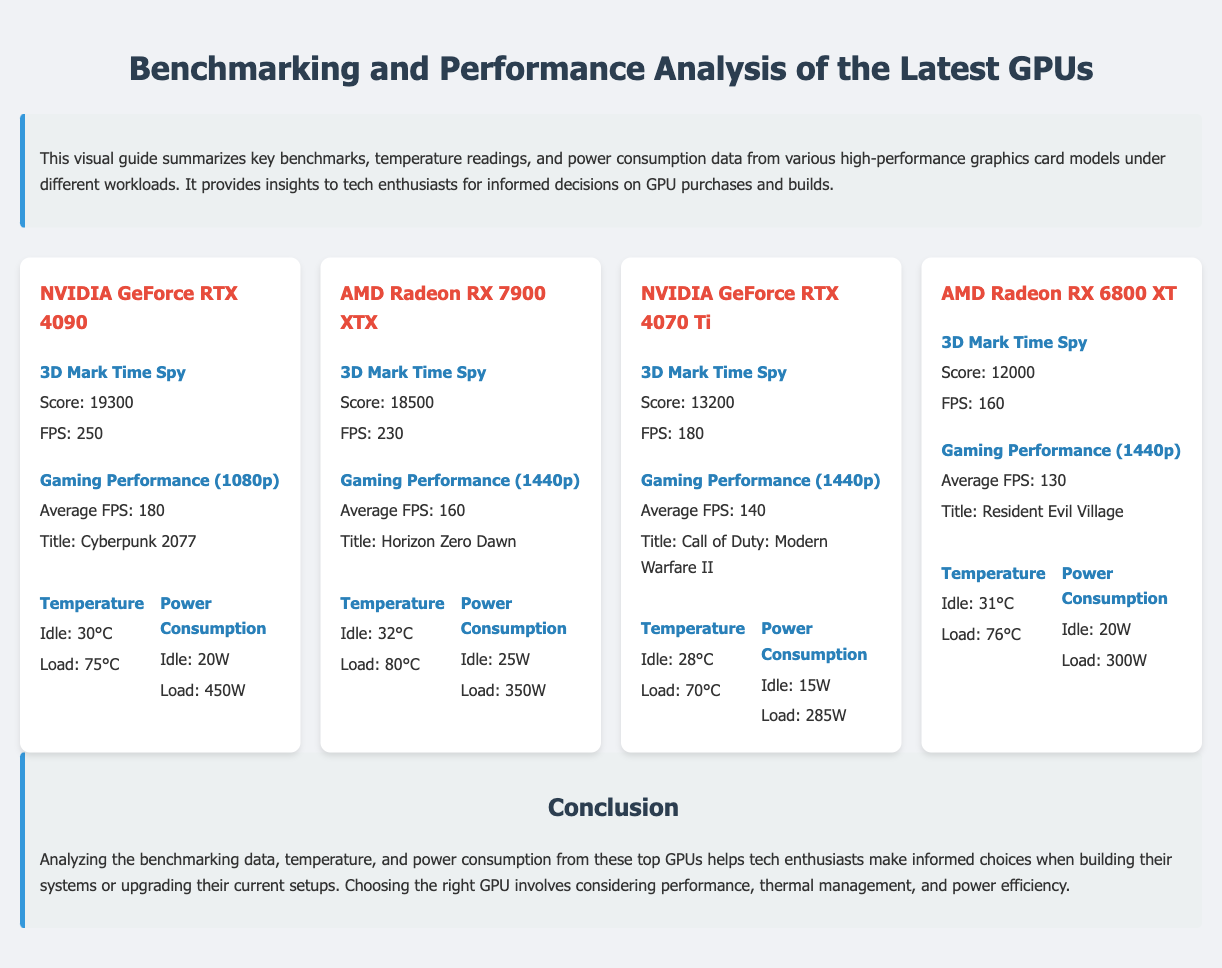What is the benchmark score for NVIDIA GeForce RTX 4090? The benchmark score for NVIDIA GeForce RTX 4090 is found in the section displaying the 3D Mark Time Spy results, which shows a score of 19300.
Answer: 19300 What is the average FPS of AMD Radeon RX 7900 XTX in Gaming Performance at 1440p? The average FPS for AMD Radeon RX 7900 XTX at 1440p is listed under Gaming Performance, showing 160 FPS for the title Horizon Zero Dawn.
Answer: 160 Which GPU has the highest power consumption at load? By analyzing power consumption data at load for all GPUs, it can be concluded that the NVIDIA GeForce RTX 4090 has the highest power consumption at 450W.
Answer: 450W What is the idle temperature of NVIDIA GeForce RTX 4070 Ti? The idle temperature for NVIDIA GeForce RTX 4070 Ti is presented in the temperature readings, showing 28°C when idle.
Answer: 28°C Which GPU has the lowest score in the 3D Mark Time Spy benchmark? The lowest score in the 3D Mark Time Spy benchmark is found under the section for AMD Radeon RX 6800 XT, which has a score of 12000.
Answer: 12000 What is the gaming title tested for the AMD Radeon RX 6800 XT? The title tested for AMD Radeon RX 6800 XT is specified under Gaming Performance, which is Resident Evil Village.
Answer: Resident Evil Village How does the load temperature of AMD Radeon RX 7900 XTX compare to NVIDIA GeForce RTX 4090? The load temperature for AMD Radeon RX 7900 XTX is 80°C, while for NVIDIA GeForce RTX 4090, it's 75°C, showing the AMD card runs hotter under load.
Answer: 80°C vs 75°C What layout style is used to present the GPUs in the document? The layout style used to present the GPUs is a grid format as indicated in the css grid-template-columns setup and described in the document's structure.
Answer: Grid format 